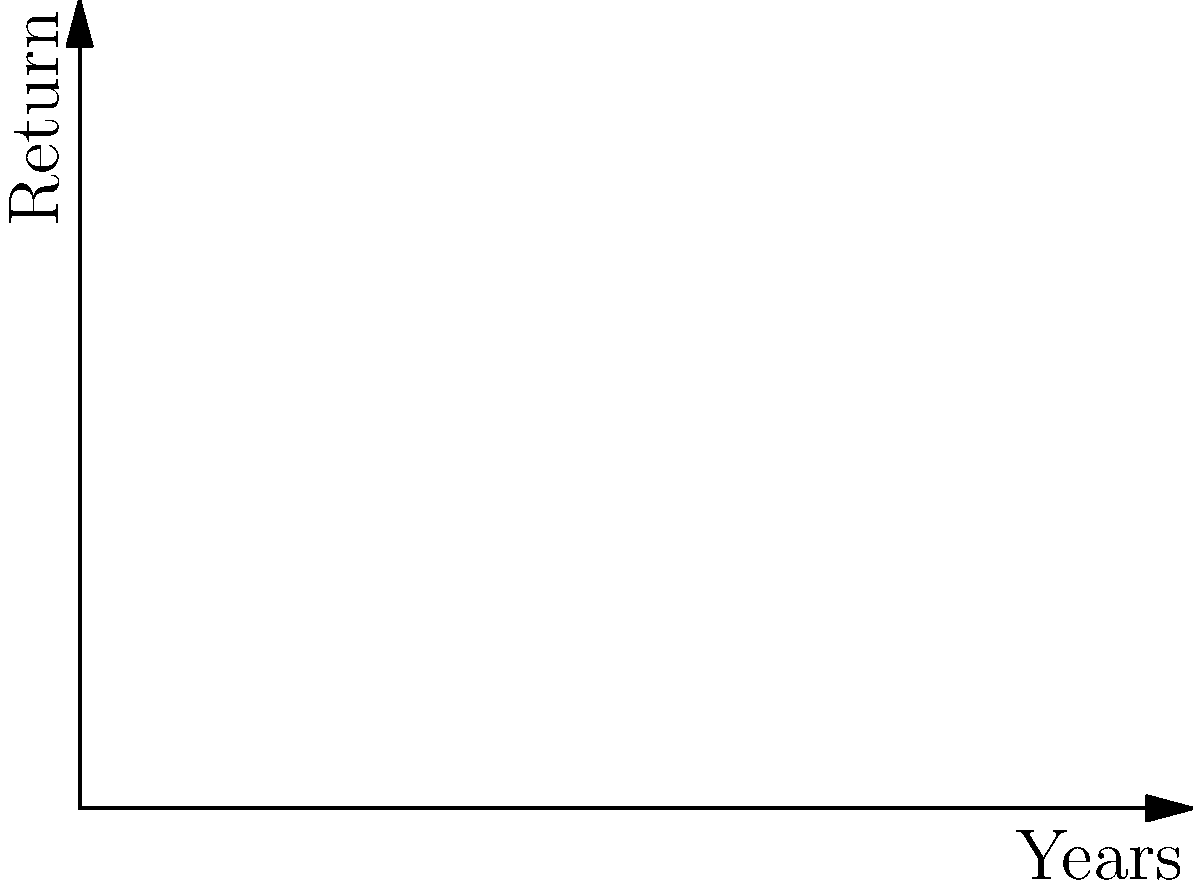Analyze the graph comparing legitimate investment returns (blue line) versus Ponzi scheme promises (red line) over a 10-year period. If an investor initially invests $10,000, what would be the approximate difference in returns between the Ponzi scheme and the legitimate investment after 10 years? Assume the legitimate investment compounds annually at 7% and the Ponzi scheme promises 20% annual returns. To solve this problem, we need to follow these steps:

1. Calculate the return for the legitimate investment:
   $10,000 \times (1.07)^{10} = 10,000 \times 1.9672 = $19,672$

2. Calculate the promised return for the Ponzi scheme:
   $10,000 \times (1.20)^{10} = 10,000 \times 6.1917 = $61,917$

3. Calculate the difference between the two:
   $61,917 - 19,672 = $42,245$

The Ponzi scheme promises approximately $42,245 more in returns compared to the legitimate investment after 10 years.

It's crucial to note that while the legitimate investment's returns are realistic and sustainable, the Ponzi scheme's promised returns are unsustainable and fraudulent. In reality, investors in a Ponzi scheme are likely to lose most or all of their initial investment.
Answer: $42,245 